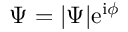Convert formula to latex. <formula><loc_0><loc_0><loc_500><loc_500>\Psi = | \Psi | e ^ { i \phi }</formula> 